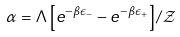<formula> <loc_0><loc_0><loc_500><loc_500>\alpha = \Lambda \left [ e ^ { - \beta \epsilon _ { - } } - e ^ { - \beta \epsilon _ { + } } \right ] / \mathcal { Z }</formula> 